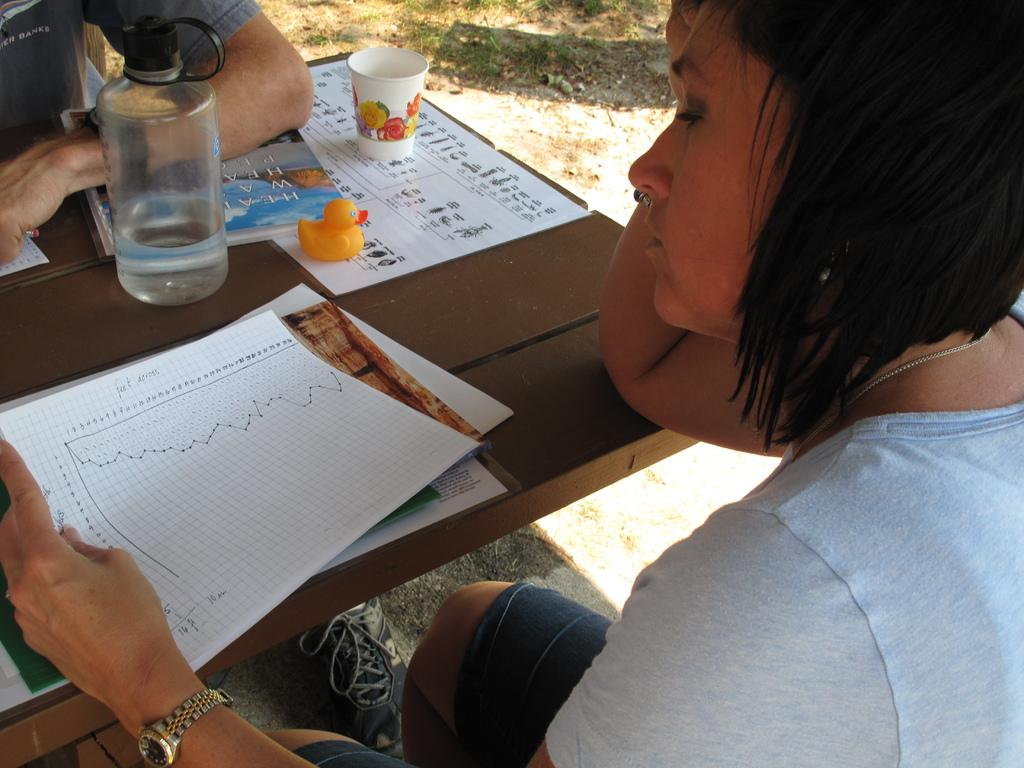What is the main object in the center of the image? There is a table in the center of the image. What items can be seen on the table? Papers, a glass, a toy, a book, a water bottle, and a paper cup are visible on the table. How many people are surrounding the table? The table is surrounded by two persons. What type of air is being discussed by the people around the table? There is no indication in the image that the people are discussing any type of air. How much debt is being handled by the toy on the table? There is no toy handling any debt in the image; it is simply a toy on the table. 